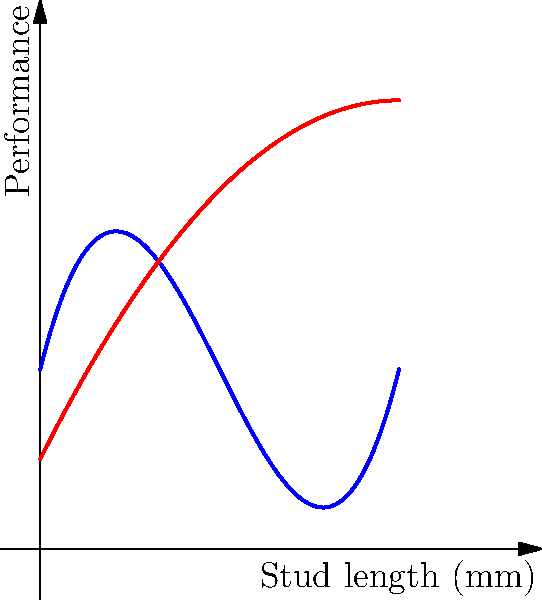The graph shows the relationship between stud length and performance for a new football cleat design. The blue curve represents traction, while the red curve represents comfort. Both are modeled using polynomial functions. If we want to maximize the combined performance (traction + comfort), what is the optimal stud length to the nearest millimeter? To find the optimal stud length, we need to follow these steps:

1. Identify the functions:
   Traction: $f(x) = 0.5x^3 - 3x^2 + 4x + 2$
   Comfort: $g(x) = -0.25x^2 + 2x + 1$

2. Create a combined performance function:
   $h(x) = f(x) + g(x) = 0.5x^3 - 3.25x^2 + 6x + 3$

3. To find the maximum, we need to find where the derivative of $h(x)$ equals zero:
   $h'(x) = 1.5x^2 - 6.5x + 6$

4. Solve the quadratic equation $1.5x^2 - 6.5x + 6 = 0$:
   Using the quadratic formula: $x = \frac{-b \pm \sqrt{b^2 - 4ac}}{2a}$
   $x = \frac{6.5 \pm \sqrt{42.25 - 36}}{3} = \frac{6.5 \pm \sqrt{6.25}}{3}$

5. Simplify:
   $x = \frac{6.5 \pm 2.5}{3}$

6. This gives us two solutions:
   $x_1 = \frac{6.5 + 2.5}{3} = 3$ and $x_2 = \frac{6.5 - 2.5}{3} = \frac{4}{3}$

7. The second solution ($\frac{4}{3}$) is outside our domain (0 to 4 mm), so we focus on $x = 3$.

8. Verify that this is a maximum by checking the second derivative:
   $h''(x) = 3x - 6.5$
   $h''(3) = 9 - 6.5 = 2.5 > 0$, confirming it's a maximum.

Therefore, the optimal stud length is 3 mm.
Answer: 3 mm 